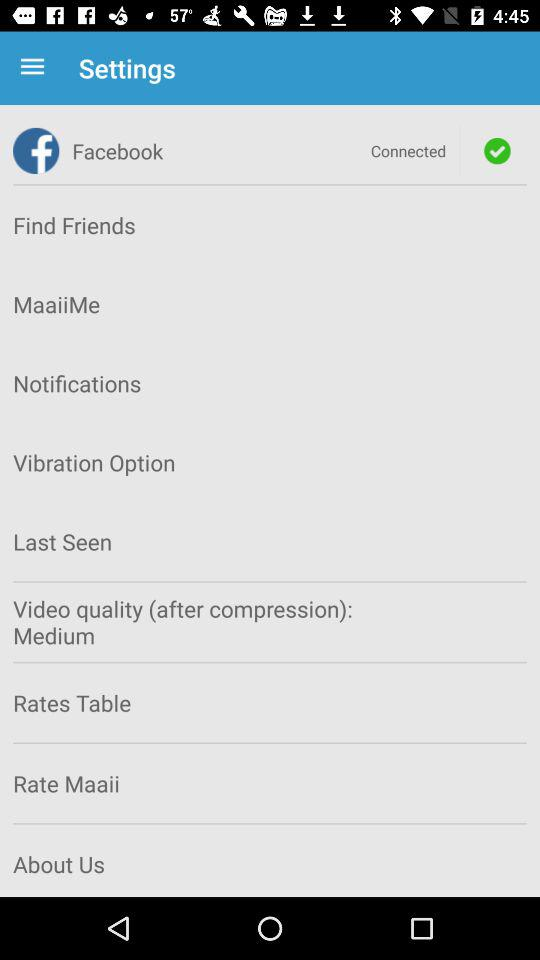What is the status of "Facebook"? The status is "on". 